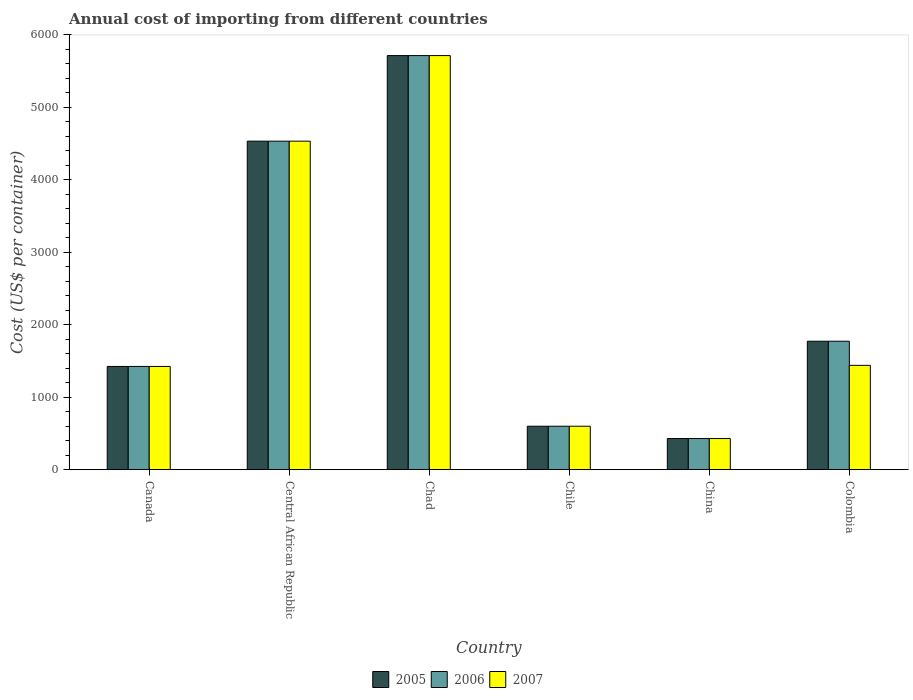How many bars are there on the 2nd tick from the right?
Ensure brevity in your answer.  3. In how many cases, is the number of bars for a given country not equal to the number of legend labels?
Your answer should be compact. 0. What is the total annual cost of importing in 2007 in Canada?
Provide a succinct answer. 1425. Across all countries, what is the maximum total annual cost of importing in 2007?
Make the answer very short. 5715. Across all countries, what is the minimum total annual cost of importing in 2007?
Your response must be concise. 430. In which country was the total annual cost of importing in 2006 maximum?
Your answer should be compact. Chad. In which country was the total annual cost of importing in 2007 minimum?
Your answer should be very brief. China. What is the total total annual cost of importing in 2005 in the graph?
Give a very brief answer. 1.45e+04. What is the difference between the total annual cost of importing in 2005 in Chile and that in Colombia?
Provide a succinct answer. -1173. What is the average total annual cost of importing in 2005 per country?
Your answer should be compact. 2412.83. In how many countries, is the total annual cost of importing in 2007 greater than 5200 US$?
Your answer should be very brief. 1. What is the ratio of the total annual cost of importing in 2007 in Central African Republic to that in Colombia?
Offer a very short reply. 3.15. What is the difference between the highest and the second highest total annual cost of importing in 2006?
Give a very brief answer. 3942. What is the difference between the highest and the lowest total annual cost of importing in 2006?
Your response must be concise. 5285. In how many countries, is the total annual cost of importing in 2006 greater than the average total annual cost of importing in 2006 taken over all countries?
Provide a short and direct response. 2. Is the sum of the total annual cost of importing in 2006 in Chile and Colombia greater than the maximum total annual cost of importing in 2005 across all countries?
Provide a short and direct response. No. What does the 1st bar from the left in Central African Republic represents?
Provide a succinct answer. 2005. What does the 2nd bar from the right in China represents?
Give a very brief answer. 2006. Is it the case that in every country, the sum of the total annual cost of importing in 2005 and total annual cost of importing in 2006 is greater than the total annual cost of importing in 2007?
Provide a succinct answer. Yes. How many bars are there?
Ensure brevity in your answer.  18. What is the difference between two consecutive major ticks on the Y-axis?
Your response must be concise. 1000. Are the values on the major ticks of Y-axis written in scientific E-notation?
Offer a terse response. No. Does the graph contain any zero values?
Offer a very short reply. No. Does the graph contain grids?
Provide a short and direct response. No. Where does the legend appear in the graph?
Provide a short and direct response. Bottom center. How many legend labels are there?
Keep it short and to the point. 3. What is the title of the graph?
Ensure brevity in your answer.  Annual cost of importing from different countries. Does "1995" appear as one of the legend labels in the graph?
Your answer should be very brief. No. What is the label or title of the X-axis?
Provide a short and direct response. Country. What is the label or title of the Y-axis?
Your answer should be compact. Cost (US$ per container). What is the Cost (US$ per container) in 2005 in Canada?
Provide a succinct answer. 1425. What is the Cost (US$ per container) of 2006 in Canada?
Provide a succinct answer. 1425. What is the Cost (US$ per container) in 2007 in Canada?
Provide a short and direct response. 1425. What is the Cost (US$ per container) of 2005 in Central African Republic?
Keep it short and to the point. 4534. What is the Cost (US$ per container) in 2006 in Central African Republic?
Give a very brief answer. 4534. What is the Cost (US$ per container) in 2007 in Central African Republic?
Make the answer very short. 4534. What is the Cost (US$ per container) in 2005 in Chad?
Provide a succinct answer. 5715. What is the Cost (US$ per container) in 2006 in Chad?
Your answer should be very brief. 5715. What is the Cost (US$ per container) in 2007 in Chad?
Your response must be concise. 5715. What is the Cost (US$ per container) of 2005 in Chile?
Your response must be concise. 600. What is the Cost (US$ per container) of 2006 in Chile?
Give a very brief answer. 600. What is the Cost (US$ per container) of 2007 in Chile?
Make the answer very short. 600. What is the Cost (US$ per container) of 2005 in China?
Make the answer very short. 430. What is the Cost (US$ per container) in 2006 in China?
Give a very brief answer. 430. What is the Cost (US$ per container) in 2007 in China?
Your answer should be compact. 430. What is the Cost (US$ per container) in 2005 in Colombia?
Your answer should be compact. 1773. What is the Cost (US$ per container) of 2006 in Colombia?
Your response must be concise. 1773. What is the Cost (US$ per container) in 2007 in Colombia?
Your answer should be compact. 1440. Across all countries, what is the maximum Cost (US$ per container) of 2005?
Provide a succinct answer. 5715. Across all countries, what is the maximum Cost (US$ per container) in 2006?
Your answer should be compact. 5715. Across all countries, what is the maximum Cost (US$ per container) of 2007?
Your response must be concise. 5715. Across all countries, what is the minimum Cost (US$ per container) in 2005?
Offer a terse response. 430. Across all countries, what is the minimum Cost (US$ per container) of 2006?
Your response must be concise. 430. Across all countries, what is the minimum Cost (US$ per container) in 2007?
Your response must be concise. 430. What is the total Cost (US$ per container) in 2005 in the graph?
Give a very brief answer. 1.45e+04. What is the total Cost (US$ per container) of 2006 in the graph?
Keep it short and to the point. 1.45e+04. What is the total Cost (US$ per container) in 2007 in the graph?
Keep it short and to the point. 1.41e+04. What is the difference between the Cost (US$ per container) in 2005 in Canada and that in Central African Republic?
Offer a very short reply. -3109. What is the difference between the Cost (US$ per container) of 2006 in Canada and that in Central African Republic?
Your answer should be compact. -3109. What is the difference between the Cost (US$ per container) of 2007 in Canada and that in Central African Republic?
Your response must be concise. -3109. What is the difference between the Cost (US$ per container) in 2005 in Canada and that in Chad?
Provide a short and direct response. -4290. What is the difference between the Cost (US$ per container) in 2006 in Canada and that in Chad?
Make the answer very short. -4290. What is the difference between the Cost (US$ per container) in 2007 in Canada and that in Chad?
Your answer should be compact. -4290. What is the difference between the Cost (US$ per container) in 2005 in Canada and that in Chile?
Keep it short and to the point. 825. What is the difference between the Cost (US$ per container) in 2006 in Canada and that in Chile?
Offer a very short reply. 825. What is the difference between the Cost (US$ per container) of 2007 in Canada and that in Chile?
Keep it short and to the point. 825. What is the difference between the Cost (US$ per container) of 2005 in Canada and that in China?
Make the answer very short. 995. What is the difference between the Cost (US$ per container) in 2006 in Canada and that in China?
Keep it short and to the point. 995. What is the difference between the Cost (US$ per container) in 2007 in Canada and that in China?
Ensure brevity in your answer.  995. What is the difference between the Cost (US$ per container) in 2005 in Canada and that in Colombia?
Offer a terse response. -348. What is the difference between the Cost (US$ per container) in 2006 in Canada and that in Colombia?
Your answer should be compact. -348. What is the difference between the Cost (US$ per container) of 2005 in Central African Republic and that in Chad?
Keep it short and to the point. -1181. What is the difference between the Cost (US$ per container) in 2006 in Central African Republic and that in Chad?
Your answer should be compact. -1181. What is the difference between the Cost (US$ per container) in 2007 in Central African Republic and that in Chad?
Provide a short and direct response. -1181. What is the difference between the Cost (US$ per container) in 2005 in Central African Republic and that in Chile?
Give a very brief answer. 3934. What is the difference between the Cost (US$ per container) of 2006 in Central African Republic and that in Chile?
Make the answer very short. 3934. What is the difference between the Cost (US$ per container) of 2007 in Central African Republic and that in Chile?
Ensure brevity in your answer.  3934. What is the difference between the Cost (US$ per container) in 2005 in Central African Republic and that in China?
Offer a terse response. 4104. What is the difference between the Cost (US$ per container) of 2006 in Central African Republic and that in China?
Provide a short and direct response. 4104. What is the difference between the Cost (US$ per container) in 2007 in Central African Republic and that in China?
Offer a very short reply. 4104. What is the difference between the Cost (US$ per container) in 2005 in Central African Republic and that in Colombia?
Provide a succinct answer. 2761. What is the difference between the Cost (US$ per container) in 2006 in Central African Republic and that in Colombia?
Offer a very short reply. 2761. What is the difference between the Cost (US$ per container) of 2007 in Central African Republic and that in Colombia?
Provide a short and direct response. 3094. What is the difference between the Cost (US$ per container) of 2005 in Chad and that in Chile?
Your response must be concise. 5115. What is the difference between the Cost (US$ per container) of 2006 in Chad and that in Chile?
Offer a very short reply. 5115. What is the difference between the Cost (US$ per container) of 2007 in Chad and that in Chile?
Keep it short and to the point. 5115. What is the difference between the Cost (US$ per container) of 2005 in Chad and that in China?
Your answer should be very brief. 5285. What is the difference between the Cost (US$ per container) of 2006 in Chad and that in China?
Give a very brief answer. 5285. What is the difference between the Cost (US$ per container) in 2007 in Chad and that in China?
Provide a succinct answer. 5285. What is the difference between the Cost (US$ per container) in 2005 in Chad and that in Colombia?
Offer a very short reply. 3942. What is the difference between the Cost (US$ per container) in 2006 in Chad and that in Colombia?
Keep it short and to the point. 3942. What is the difference between the Cost (US$ per container) of 2007 in Chad and that in Colombia?
Offer a terse response. 4275. What is the difference between the Cost (US$ per container) in 2005 in Chile and that in China?
Provide a succinct answer. 170. What is the difference between the Cost (US$ per container) of 2006 in Chile and that in China?
Your answer should be very brief. 170. What is the difference between the Cost (US$ per container) of 2007 in Chile and that in China?
Keep it short and to the point. 170. What is the difference between the Cost (US$ per container) of 2005 in Chile and that in Colombia?
Make the answer very short. -1173. What is the difference between the Cost (US$ per container) of 2006 in Chile and that in Colombia?
Give a very brief answer. -1173. What is the difference between the Cost (US$ per container) of 2007 in Chile and that in Colombia?
Your answer should be compact. -840. What is the difference between the Cost (US$ per container) in 2005 in China and that in Colombia?
Provide a short and direct response. -1343. What is the difference between the Cost (US$ per container) of 2006 in China and that in Colombia?
Give a very brief answer. -1343. What is the difference between the Cost (US$ per container) in 2007 in China and that in Colombia?
Make the answer very short. -1010. What is the difference between the Cost (US$ per container) in 2005 in Canada and the Cost (US$ per container) in 2006 in Central African Republic?
Offer a very short reply. -3109. What is the difference between the Cost (US$ per container) in 2005 in Canada and the Cost (US$ per container) in 2007 in Central African Republic?
Ensure brevity in your answer.  -3109. What is the difference between the Cost (US$ per container) of 2006 in Canada and the Cost (US$ per container) of 2007 in Central African Republic?
Offer a terse response. -3109. What is the difference between the Cost (US$ per container) in 2005 in Canada and the Cost (US$ per container) in 2006 in Chad?
Offer a terse response. -4290. What is the difference between the Cost (US$ per container) of 2005 in Canada and the Cost (US$ per container) of 2007 in Chad?
Give a very brief answer. -4290. What is the difference between the Cost (US$ per container) of 2006 in Canada and the Cost (US$ per container) of 2007 in Chad?
Make the answer very short. -4290. What is the difference between the Cost (US$ per container) in 2005 in Canada and the Cost (US$ per container) in 2006 in Chile?
Your response must be concise. 825. What is the difference between the Cost (US$ per container) of 2005 in Canada and the Cost (US$ per container) of 2007 in Chile?
Provide a succinct answer. 825. What is the difference between the Cost (US$ per container) in 2006 in Canada and the Cost (US$ per container) in 2007 in Chile?
Ensure brevity in your answer.  825. What is the difference between the Cost (US$ per container) of 2005 in Canada and the Cost (US$ per container) of 2006 in China?
Provide a succinct answer. 995. What is the difference between the Cost (US$ per container) of 2005 in Canada and the Cost (US$ per container) of 2007 in China?
Your answer should be very brief. 995. What is the difference between the Cost (US$ per container) of 2006 in Canada and the Cost (US$ per container) of 2007 in China?
Your answer should be very brief. 995. What is the difference between the Cost (US$ per container) in 2005 in Canada and the Cost (US$ per container) in 2006 in Colombia?
Keep it short and to the point. -348. What is the difference between the Cost (US$ per container) in 2005 in Canada and the Cost (US$ per container) in 2007 in Colombia?
Make the answer very short. -15. What is the difference between the Cost (US$ per container) of 2005 in Central African Republic and the Cost (US$ per container) of 2006 in Chad?
Offer a terse response. -1181. What is the difference between the Cost (US$ per container) in 2005 in Central African Republic and the Cost (US$ per container) in 2007 in Chad?
Make the answer very short. -1181. What is the difference between the Cost (US$ per container) of 2006 in Central African Republic and the Cost (US$ per container) of 2007 in Chad?
Provide a short and direct response. -1181. What is the difference between the Cost (US$ per container) in 2005 in Central African Republic and the Cost (US$ per container) in 2006 in Chile?
Provide a succinct answer. 3934. What is the difference between the Cost (US$ per container) in 2005 in Central African Republic and the Cost (US$ per container) in 2007 in Chile?
Provide a succinct answer. 3934. What is the difference between the Cost (US$ per container) of 2006 in Central African Republic and the Cost (US$ per container) of 2007 in Chile?
Your answer should be very brief. 3934. What is the difference between the Cost (US$ per container) in 2005 in Central African Republic and the Cost (US$ per container) in 2006 in China?
Offer a very short reply. 4104. What is the difference between the Cost (US$ per container) of 2005 in Central African Republic and the Cost (US$ per container) of 2007 in China?
Make the answer very short. 4104. What is the difference between the Cost (US$ per container) of 2006 in Central African Republic and the Cost (US$ per container) of 2007 in China?
Your answer should be very brief. 4104. What is the difference between the Cost (US$ per container) in 2005 in Central African Republic and the Cost (US$ per container) in 2006 in Colombia?
Your response must be concise. 2761. What is the difference between the Cost (US$ per container) of 2005 in Central African Republic and the Cost (US$ per container) of 2007 in Colombia?
Provide a short and direct response. 3094. What is the difference between the Cost (US$ per container) in 2006 in Central African Republic and the Cost (US$ per container) in 2007 in Colombia?
Your answer should be compact. 3094. What is the difference between the Cost (US$ per container) of 2005 in Chad and the Cost (US$ per container) of 2006 in Chile?
Provide a short and direct response. 5115. What is the difference between the Cost (US$ per container) in 2005 in Chad and the Cost (US$ per container) in 2007 in Chile?
Make the answer very short. 5115. What is the difference between the Cost (US$ per container) of 2006 in Chad and the Cost (US$ per container) of 2007 in Chile?
Provide a succinct answer. 5115. What is the difference between the Cost (US$ per container) in 2005 in Chad and the Cost (US$ per container) in 2006 in China?
Keep it short and to the point. 5285. What is the difference between the Cost (US$ per container) of 2005 in Chad and the Cost (US$ per container) of 2007 in China?
Your answer should be compact. 5285. What is the difference between the Cost (US$ per container) in 2006 in Chad and the Cost (US$ per container) in 2007 in China?
Your response must be concise. 5285. What is the difference between the Cost (US$ per container) in 2005 in Chad and the Cost (US$ per container) in 2006 in Colombia?
Ensure brevity in your answer.  3942. What is the difference between the Cost (US$ per container) of 2005 in Chad and the Cost (US$ per container) of 2007 in Colombia?
Your response must be concise. 4275. What is the difference between the Cost (US$ per container) in 2006 in Chad and the Cost (US$ per container) in 2007 in Colombia?
Your answer should be compact. 4275. What is the difference between the Cost (US$ per container) of 2005 in Chile and the Cost (US$ per container) of 2006 in China?
Give a very brief answer. 170. What is the difference between the Cost (US$ per container) in 2005 in Chile and the Cost (US$ per container) in 2007 in China?
Make the answer very short. 170. What is the difference between the Cost (US$ per container) in 2006 in Chile and the Cost (US$ per container) in 2007 in China?
Your answer should be very brief. 170. What is the difference between the Cost (US$ per container) of 2005 in Chile and the Cost (US$ per container) of 2006 in Colombia?
Provide a short and direct response. -1173. What is the difference between the Cost (US$ per container) in 2005 in Chile and the Cost (US$ per container) in 2007 in Colombia?
Your response must be concise. -840. What is the difference between the Cost (US$ per container) of 2006 in Chile and the Cost (US$ per container) of 2007 in Colombia?
Ensure brevity in your answer.  -840. What is the difference between the Cost (US$ per container) in 2005 in China and the Cost (US$ per container) in 2006 in Colombia?
Offer a very short reply. -1343. What is the difference between the Cost (US$ per container) of 2005 in China and the Cost (US$ per container) of 2007 in Colombia?
Give a very brief answer. -1010. What is the difference between the Cost (US$ per container) of 2006 in China and the Cost (US$ per container) of 2007 in Colombia?
Give a very brief answer. -1010. What is the average Cost (US$ per container) in 2005 per country?
Give a very brief answer. 2412.83. What is the average Cost (US$ per container) of 2006 per country?
Give a very brief answer. 2412.83. What is the average Cost (US$ per container) of 2007 per country?
Your response must be concise. 2357.33. What is the difference between the Cost (US$ per container) of 2005 and Cost (US$ per container) of 2007 in Canada?
Your response must be concise. 0. What is the difference between the Cost (US$ per container) of 2006 and Cost (US$ per container) of 2007 in Canada?
Keep it short and to the point. 0. What is the difference between the Cost (US$ per container) in 2005 and Cost (US$ per container) in 2006 in Central African Republic?
Your answer should be compact. 0. What is the difference between the Cost (US$ per container) in 2005 and Cost (US$ per container) in 2007 in Central African Republic?
Make the answer very short. 0. What is the difference between the Cost (US$ per container) in 2005 and Cost (US$ per container) in 2007 in Chad?
Your answer should be compact. 0. What is the difference between the Cost (US$ per container) of 2005 and Cost (US$ per container) of 2007 in Chile?
Make the answer very short. 0. What is the difference between the Cost (US$ per container) in 2006 and Cost (US$ per container) in 2007 in Chile?
Your response must be concise. 0. What is the difference between the Cost (US$ per container) in 2005 and Cost (US$ per container) in 2006 in China?
Make the answer very short. 0. What is the difference between the Cost (US$ per container) in 2005 and Cost (US$ per container) in 2007 in Colombia?
Ensure brevity in your answer.  333. What is the difference between the Cost (US$ per container) in 2006 and Cost (US$ per container) in 2007 in Colombia?
Make the answer very short. 333. What is the ratio of the Cost (US$ per container) in 2005 in Canada to that in Central African Republic?
Provide a succinct answer. 0.31. What is the ratio of the Cost (US$ per container) in 2006 in Canada to that in Central African Republic?
Provide a short and direct response. 0.31. What is the ratio of the Cost (US$ per container) of 2007 in Canada to that in Central African Republic?
Make the answer very short. 0.31. What is the ratio of the Cost (US$ per container) in 2005 in Canada to that in Chad?
Your answer should be very brief. 0.25. What is the ratio of the Cost (US$ per container) of 2006 in Canada to that in Chad?
Offer a terse response. 0.25. What is the ratio of the Cost (US$ per container) of 2007 in Canada to that in Chad?
Your response must be concise. 0.25. What is the ratio of the Cost (US$ per container) of 2005 in Canada to that in Chile?
Give a very brief answer. 2.38. What is the ratio of the Cost (US$ per container) of 2006 in Canada to that in Chile?
Give a very brief answer. 2.38. What is the ratio of the Cost (US$ per container) in 2007 in Canada to that in Chile?
Your answer should be compact. 2.38. What is the ratio of the Cost (US$ per container) in 2005 in Canada to that in China?
Your response must be concise. 3.31. What is the ratio of the Cost (US$ per container) of 2006 in Canada to that in China?
Provide a short and direct response. 3.31. What is the ratio of the Cost (US$ per container) of 2007 in Canada to that in China?
Keep it short and to the point. 3.31. What is the ratio of the Cost (US$ per container) in 2005 in Canada to that in Colombia?
Offer a very short reply. 0.8. What is the ratio of the Cost (US$ per container) in 2006 in Canada to that in Colombia?
Ensure brevity in your answer.  0.8. What is the ratio of the Cost (US$ per container) of 2007 in Canada to that in Colombia?
Your response must be concise. 0.99. What is the ratio of the Cost (US$ per container) in 2005 in Central African Republic to that in Chad?
Provide a succinct answer. 0.79. What is the ratio of the Cost (US$ per container) of 2006 in Central African Republic to that in Chad?
Your answer should be very brief. 0.79. What is the ratio of the Cost (US$ per container) of 2007 in Central African Republic to that in Chad?
Your response must be concise. 0.79. What is the ratio of the Cost (US$ per container) of 2005 in Central African Republic to that in Chile?
Offer a terse response. 7.56. What is the ratio of the Cost (US$ per container) of 2006 in Central African Republic to that in Chile?
Keep it short and to the point. 7.56. What is the ratio of the Cost (US$ per container) of 2007 in Central African Republic to that in Chile?
Make the answer very short. 7.56. What is the ratio of the Cost (US$ per container) in 2005 in Central African Republic to that in China?
Offer a very short reply. 10.54. What is the ratio of the Cost (US$ per container) of 2006 in Central African Republic to that in China?
Offer a very short reply. 10.54. What is the ratio of the Cost (US$ per container) in 2007 in Central African Republic to that in China?
Ensure brevity in your answer.  10.54. What is the ratio of the Cost (US$ per container) of 2005 in Central African Republic to that in Colombia?
Offer a very short reply. 2.56. What is the ratio of the Cost (US$ per container) in 2006 in Central African Republic to that in Colombia?
Offer a very short reply. 2.56. What is the ratio of the Cost (US$ per container) in 2007 in Central African Republic to that in Colombia?
Ensure brevity in your answer.  3.15. What is the ratio of the Cost (US$ per container) in 2005 in Chad to that in Chile?
Give a very brief answer. 9.53. What is the ratio of the Cost (US$ per container) of 2006 in Chad to that in Chile?
Provide a short and direct response. 9.53. What is the ratio of the Cost (US$ per container) in 2007 in Chad to that in Chile?
Make the answer very short. 9.53. What is the ratio of the Cost (US$ per container) of 2005 in Chad to that in China?
Your response must be concise. 13.29. What is the ratio of the Cost (US$ per container) in 2006 in Chad to that in China?
Keep it short and to the point. 13.29. What is the ratio of the Cost (US$ per container) in 2007 in Chad to that in China?
Ensure brevity in your answer.  13.29. What is the ratio of the Cost (US$ per container) of 2005 in Chad to that in Colombia?
Ensure brevity in your answer.  3.22. What is the ratio of the Cost (US$ per container) of 2006 in Chad to that in Colombia?
Ensure brevity in your answer.  3.22. What is the ratio of the Cost (US$ per container) of 2007 in Chad to that in Colombia?
Your response must be concise. 3.97. What is the ratio of the Cost (US$ per container) of 2005 in Chile to that in China?
Provide a succinct answer. 1.4. What is the ratio of the Cost (US$ per container) of 2006 in Chile to that in China?
Your response must be concise. 1.4. What is the ratio of the Cost (US$ per container) of 2007 in Chile to that in China?
Your response must be concise. 1.4. What is the ratio of the Cost (US$ per container) of 2005 in Chile to that in Colombia?
Ensure brevity in your answer.  0.34. What is the ratio of the Cost (US$ per container) of 2006 in Chile to that in Colombia?
Your response must be concise. 0.34. What is the ratio of the Cost (US$ per container) of 2007 in Chile to that in Colombia?
Provide a short and direct response. 0.42. What is the ratio of the Cost (US$ per container) in 2005 in China to that in Colombia?
Keep it short and to the point. 0.24. What is the ratio of the Cost (US$ per container) of 2006 in China to that in Colombia?
Your response must be concise. 0.24. What is the ratio of the Cost (US$ per container) of 2007 in China to that in Colombia?
Your response must be concise. 0.3. What is the difference between the highest and the second highest Cost (US$ per container) in 2005?
Your answer should be compact. 1181. What is the difference between the highest and the second highest Cost (US$ per container) in 2006?
Provide a short and direct response. 1181. What is the difference between the highest and the second highest Cost (US$ per container) in 2007?
Provide a succinct answer. 1181. What is the difference between the highest and the lowest Cost (US$ per container) of 2005?
Offer a terse response. 5285. What is the difference between the highest and the lowest Cost (US$ per container) in 2006?
Offer a terse response. 5285. What is the difference between the highest and the lowest Cost (US$ per container) in 2007?
Offer a terse response. 5285. 